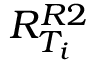<formula> <loc_0><loc_0><loc_500><loc_500>R _ { T _ { i } } ^ { R 2 }</formula> 